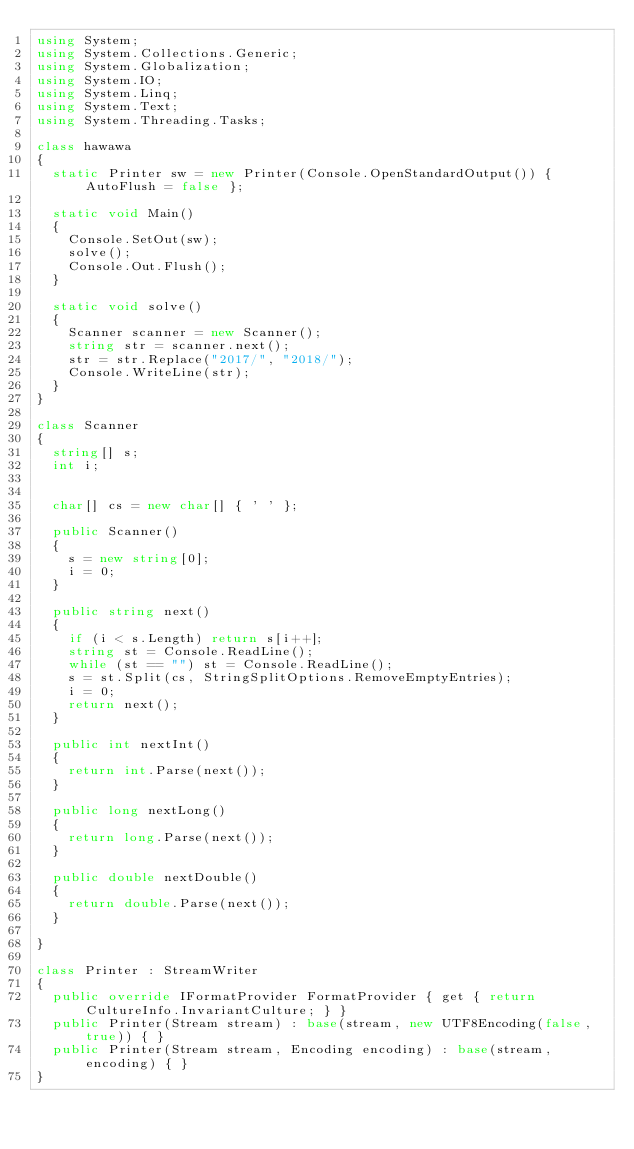Convert code to text. <code><loc_0><loc_0><loc_500><loc_500><_C#_>using System;
using System.Collections.Generic;
using System.Globalization;
using System.IO;
using System.Linq;
using System.Text;
using System.Threading.Tasks;

class hawawa
{
  static Printer sw = new Printer(Console.OpenStandardOutput()) { AutoFlush = false };

  static void Main()
  {
    Console.SetOut(sw);
    solve();
    Console.Out.Flush();
  }

  static void solve()
  {
    Scanner scanner = new Scanner();
    string str = scanner.next();
    str = str.Replace("2017/", "2018/");
    Console.WriteLine(str);
  }
}

class Scanner
{
  string[] s;
  int i;


  char[] cs = new char[] { ' ' };

  public Scanner()
  {
    s = new string[0];
    i = 0;
  }

  public string next()
  {
    if (i < s.Length) return s[i++];
    string st = Console.ReadLine();
    while (st == "") st = Console.ReadLine();
    s = st.Split(cs, StringSplitOptions.RemoveEmptyEntries);
    i = 0;
    return next();
  }

  public int nextInt()
  {
    return int.Parse(next());
  }

  public long nextLong()
  {
    return long.Parse(next());
  }

  public double nextDouble()
  {
    return double.Parse(next());
  }

}

class Printer : StreamWriter
{
  public override IFormatProvider FormatProvider { get { return CultureInfo.InvariantCulture; } }
  public Printer(Stream stream) : base(stream, new UTF8Encoding(false, true)) { }
  public Printer(Stream stream, Encoding encoding) : base(stream, encoding) { }
}
</code> 